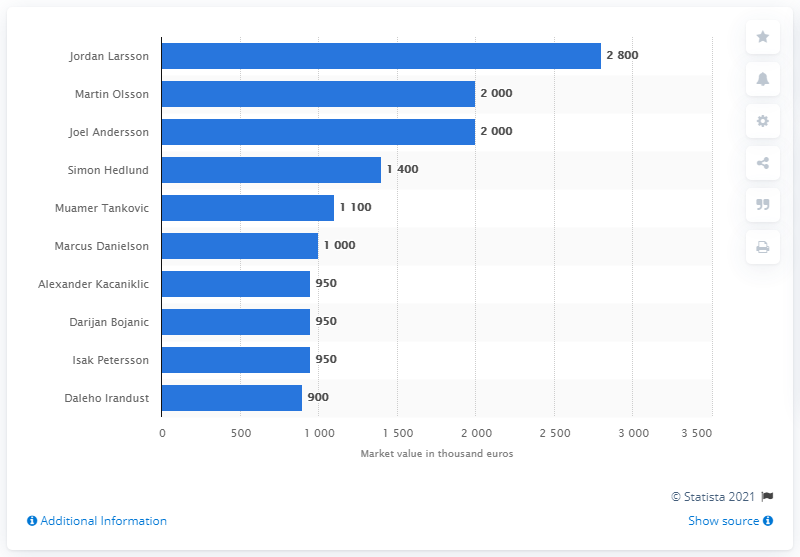Give some essential details in this illustration. Jordan Larsson was declared the most valuable player of the Swedish national football team in 2020. In 2020, Simon Hedlund was the most valuable player on the Swedish national football team. 